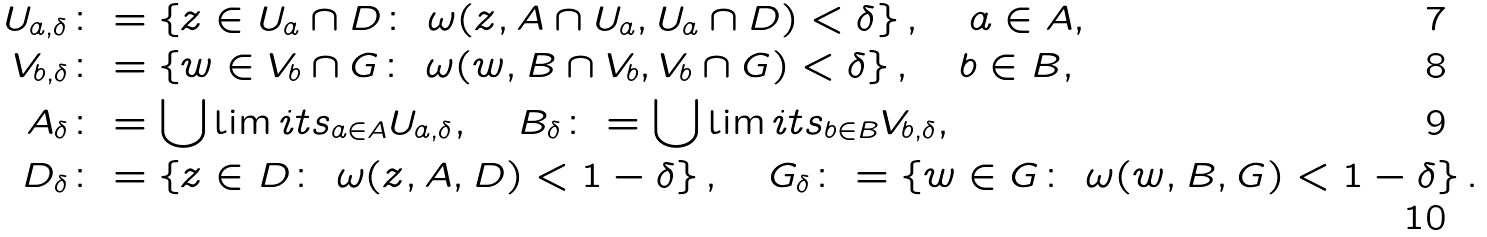Convert formula to latex. <formula><loc_0><loc_0><loc_500><loc_500>U _ { a , \delta } & \colon = \left \{ z \in U _ { a } \cap D \colon \ \omega ( z , A \cap U _ { a } , U _ { a } \cap D ) < \delta \right \} , \quad a \in A , \\ V _ { b , \delta } & \colon = \left \{ w \in V _ { b } \cap G \colon \ \omega ( w , B \cap V _ { b } , V _ { b } \cap G ) < \delta \right \} , \quad b \in B , \\ A _ { \delta } & \colon = \bigcup \lim i t s _ { a \in A } U _ { a , \delta } , \quad B _ { \delta } \colon = \bigcup \lim i t s _ { b \in B } V _ { b , \delta } , \\ D _ { \delta } & \colon = \left \{ z \in D \colon \ \omega ( z , A , D ) < 1 - \delta \right \} , \quad G _ { \delta } \colon = \left \{ w \in G \colon \ \omega ( w , B , G ) < 1 - \delta \right \} .</formula> 